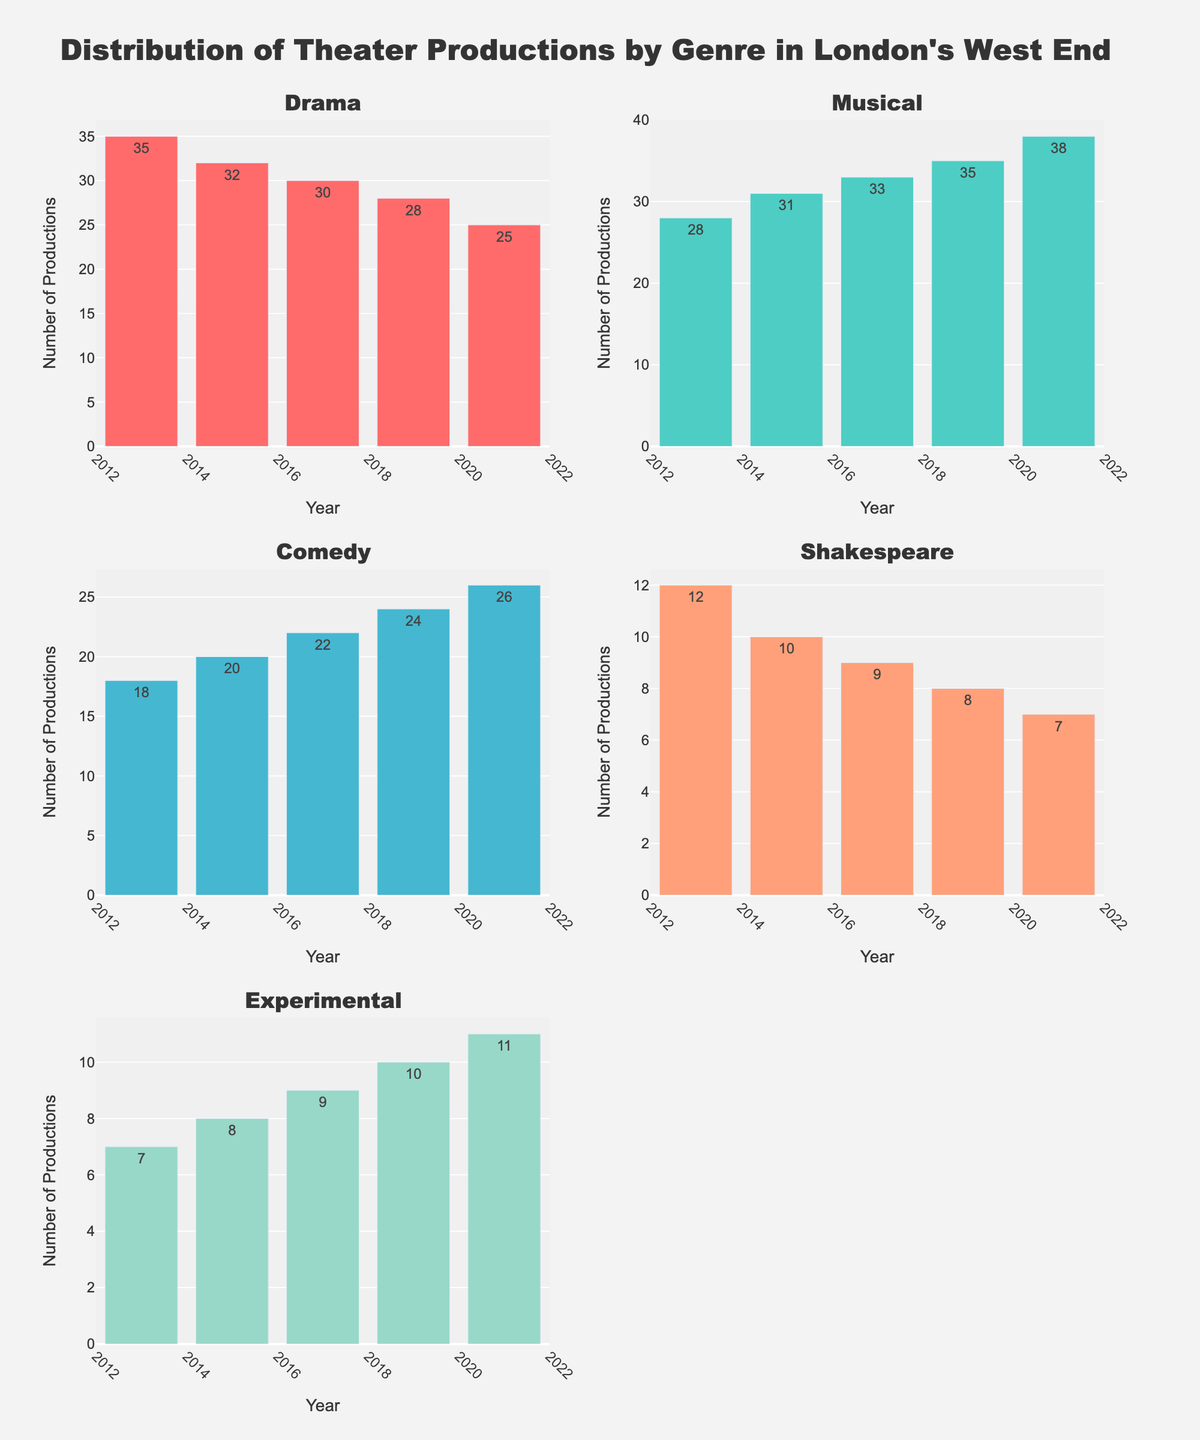What is the color of the bar representing Shakespeare productions? The color of the bar representing Shakespeare productions can be identified by looking at the subplot titled "Shakespeare." The bars for Shakespeare productions are colored in a shade that resembles light salmon.
Answer: Light salmon In which year were there the most Drama productions? By examining the Drama subplot, the tallest bar represents the year with the most productions. The 2013 bar is the tallest, indicating 35 Drama productions.
Answer: 2013 How many more Musical productions were there in 2021 compared to 2013? To find the difference in Musical productions between 2021 and 2013, look at the heights of the bars for these years in the Musical subplot. In 2013, there were 28 Musical productions, and in 2021, there were 38. The difference is 38 - 28.
Answer: 10 Which genre had the highest number of productions in 2019? By visually comparing the heights of all bars in their respective subplots for the year 2019, it is clear that the Musical subplot has the highest bar for that year, representing 35 productions.
Answer: Musical What is the average number of Shakespeare productions across the given years? To find the average, sum the number of Shakespeare productions from each year (12 + 10 + 9 + 8 + 7) and then divide by the total number of years, which is 5. (12 + 10 + 9 + 8 + 7) / 5 = 46 / 5 = 9.2
Answer: 9.2 Which genre saw the least increase in the number of productions from 2013 to 2021? By calculating the difference for each genre between 2013 and 2021:
- Drama: 35 - 25 = 10
- Musical: 38 - 28 = 10
- Comedy: 26 - 18 = 8
- Shakespeare: 7 - 12 = -5 (decrease)
- Experimental: 11 - 7 = 4
Experimental had the least increase of 4.
Answer: Experimental How many genres had fewer productions in 2021 compared to 2013? By comparing the number of productions for each genre in 2021 with 2013:
- Drama: 25 < 35 (true)
- Musical: 38 > 28 (false)
- Comedy: 26 > 18 (false)
- Shakespeare: 7 < 12 (true)
- Experimental: 11 > 7 (false)
Only Drama and Shakespeare had fewer productions in 2021 compared to 2013.
Answer: 2 Which year saw the highest number of Experimental productions? By observing the Experimental subplot, the tallest bar indicates the year with the most productions. The tallest bar is in 2021, representing 11 productions.
Answer: 2021 